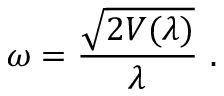Convert formula to latex. <formula><loc_0><loc_0><loc_500><loc_500>\omega = \frac { \sqrt { 2 V ( \lambda ) } } { \lambda } .</formula> 